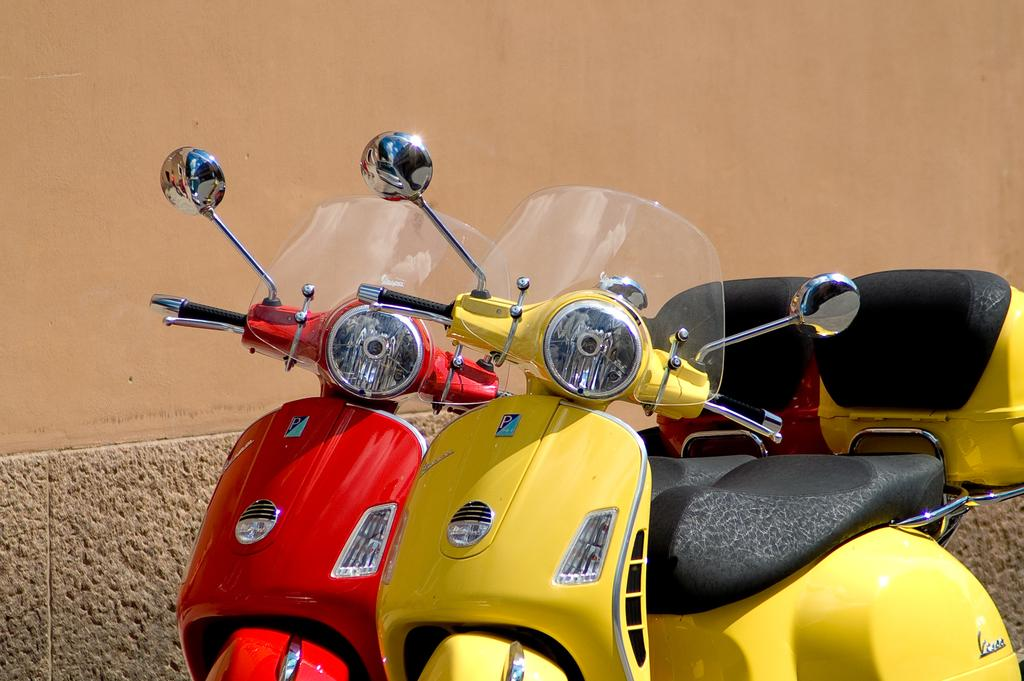What type of vehicles are in the image? There are two motorcycles in the image. What is the status of the motorcycles in the image? The motorcycles are parked. What colors are the motorcycles in the image? One motorcycle is yellow, and the other is red. What can be seen in the background of the image? There is a wall in the background of the image. Where is the grandmother sitting in the image? There is no grandmother present in the image; it only features two parked motorcycles and a wall in the background. 